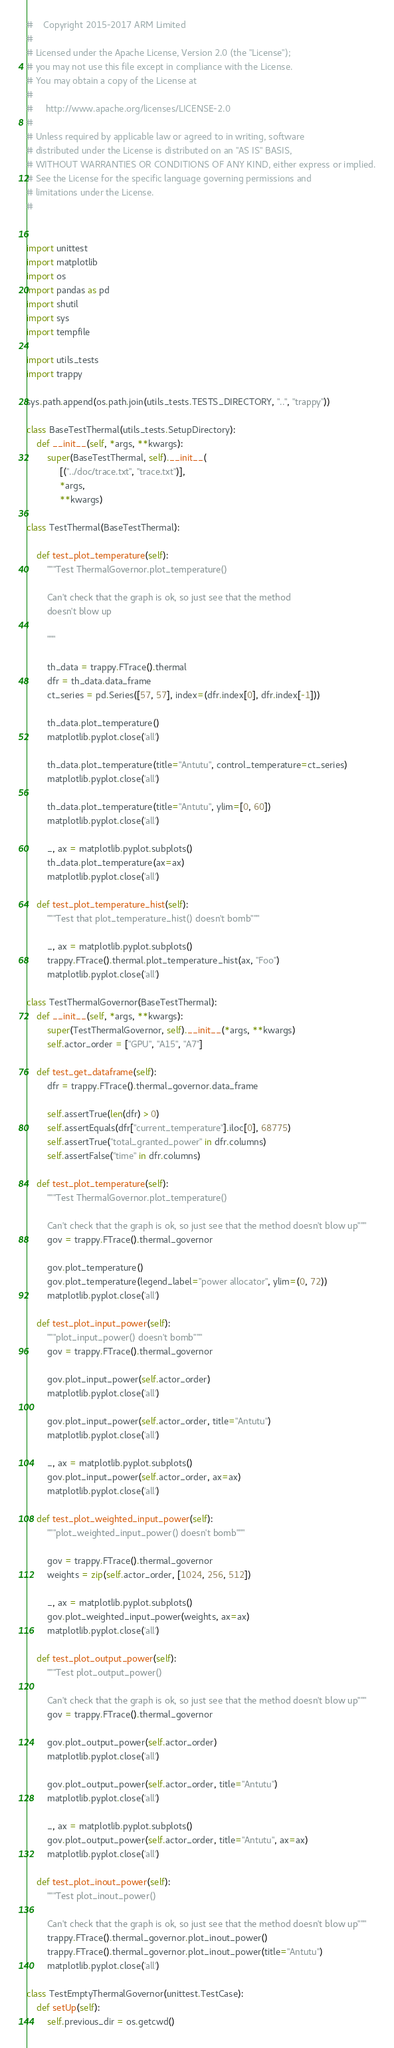Convert code to text. <code><loc_0><loc_0><loc_500><loc_500><_Python_>#    Copyright 2015-2017 ARM Limited
#
# Licensed under the Apache License, Version 2.0 (the "License");
# you may not use this file except in compliance with the License.
# You may obtain a copy of the License at
#
#     http://www.apache.org/licenses/LICENSE-2.0
#
# Unless required by applicable law or agreed to in writing, software
# distributed under the License is distributed on an "AS IS" BASIS,
# WITHOUT WARRANTIES OR CONDITIONS OF ANY KIND, either express or implied.
# See the License for the specific language governing permissions and
# limitations under the License.
#


import unittest
import matplotlib
import os
import pandas as pd
import shutil
import sys
import tempfile

import utils_tests
import trappy

sys.path.append(os.path.join(utils_tests.TESTS_DIRECTORY, "..", "trappy"))

class BaseTestThermal(utils_tests.SetupDirectory):
    def __init__(self, *args, **kwargs):
        super(BaseTestThermal, self).__init__(
             [("../doc/trace.txt", "trace.txt")],
             *args,
             **kwargs)

class TestThermal(BaseTestThermal):

    def test_plot_temperature(self):
        """Test ThermalGovernor.plot_temperature()

        Can't check that the graph is ok, so just see that the method
        doesn't blow up

        """

        th_data = trappy.FTrace().thermal
        dfr = th_data.data_frame
        ct_series = pd.Series([57, 57], index=(dfr.index[0], dfr.index[-1]))

        th_data.plot_temperature()
        matplotlib.pyplot.close('all')

        th_data.plot_temperature(title="Antutu", control_temperature=ct_series)
        matplotlib.pyplot.close('all')

        th_data.plot_temperature(title="Antutu", ylim=[0, 60])
        matplotlib.pyplot.close('all')

        _, ax = matplotlib.pyplot.subplots()
        th_data.plot_temperature(ax=ax)
        matplotlib.pyplot.close('all')

    def test_plot_temperature_hist(self):
        """Test that plot_temperature_hist() doesn't bomb"""

        _, ax = matplotlib.pyplot.subplots()
        trappy.FTrace().thermal.plot_temperature_hist(ax, "Foo")
        matplotlib.pyplot.close('all')

class TestThermalGovernor(BaseTestThermal):
    def __init__(self, *args, **kwargs):
        super(TestThermalGovernor, self).__init__(*args, **kwargs)
        self.actor_order = ["GPU", "A15", "A7"]

    def test_get_dataframe(self):
        dfr = trappy.FTrace().thermal_governor.data_frame

        self.assertTrue(len(dfr) > 0)
        self.assertEquals(dfr["current_temperature"].iloc[0], 68775)
        self.assertTrue("total_granted_power" in dfr.columns)
        self.assertFalse("time" in dfr.columns)

    def test_plot_temperature(self):
        """Test ThermalGovernor.plot_temperature()

        Can't check that the graph is ok, so just see that the method doesn't blow up"""
        gov = trappy.FTrace().thermal_governor

        gov.plot_temperature()
        gov.plot_temperature(legend_label="power allocator", ylim=(0, 72))
        matplotlib.pyplot.close('all')

    def test_plot_input_power(self):
        """plot_input_power() doesn't bomb"""
        gov = trappy.FTrace().thermal_governor

        gov.plot_input_power(self.actor_order)
        matplotlib.pyplot.close('all')

        gov.plot_input_power(self.actor_order, title="Antutu")
        matplotlib.pyplot.close('all')

        _, ax = matplotlib.pyplot.subplots()
        gov.plot_input_power(self.actor_order, ax=ax)
        matplotlib.pyplot.close('all')

    def test_plot_weighted_input_power(self):
        """plot_weighted_input_power() doesn't bomb"""

        gov = trappy.FTrace().thermal_governor
        weights = zip(self.actor_order, [1024, 256, 512])

        _, ax = matplotlib.pyplot.subplots()
        gov.plot_weighted_input_power(weights, ax=ax)
        matplotlib.pyplot.close('all')

    def test_plot_output_power(self):
        """Test plot_output_power()

        Can't check that the graph is ok, so just see that the method doesn't blow up"""
        gov = trappy.FTrace().thermal_governor

        gov.plot_output_power(self.actor_order)
        matplotlib.pyplot.close('all')

        gov.plot_output_power(self.actor_order, title="Antutu")
        matplotlib.pyplot.close('all')

        _, ax = matplotlib.pyplot.subplots()
        gov.plot_output_power(self.actor_order, title="Antutu", ax=ax)
        matplotlib.pyplot.close('all')

    def test_plot_inout_power(self):
        """Test plot_inout_power()

        Can't check that the graph is ok, so just see that the method doesn't blow up"""
        trappy.FTrace().thermal_governor.plot_inout_power()
        trappy.FTrace().thermal_governor.plot_inout_power(title="Antutu")
        matplotlib.pyplot.close('all')

class TestEmptyThermalGovernor(unittest.TestCase):
    def setUp(self):
        self.previous_dir = os.getcwd()</code> 